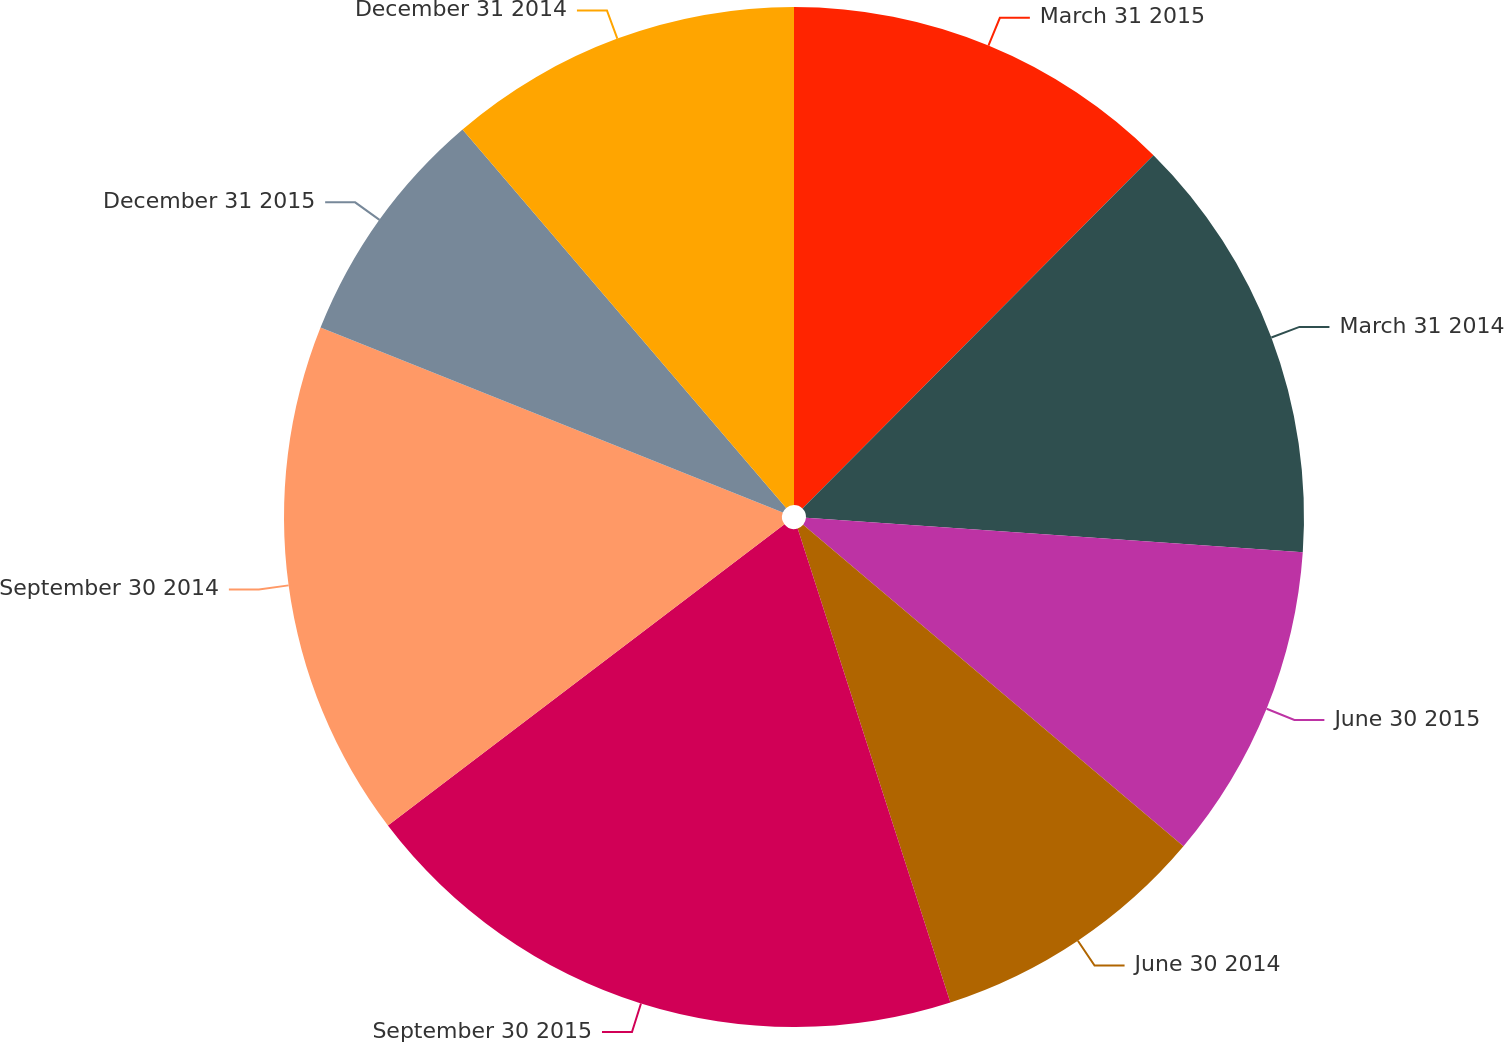Convert chart to OTSL. <chart><loc_0><loc_0><loc_500><loc_500><pie_chart><fcel>March 31 2015<fcel>March 31 2014<fcel>June 30 2015<fcel>June 30 2014<fcel>September 30 2015<fcel>September 30 2014<fcel>December 31 2015<fcel>December 31 2014<nl><fcel>12.45%<fcel>13.65%<fcel>10.07%<fcel>8.87%<fcel>19.62%<fcel>16.4%<fcel>7.68%<fcel>11.26%<nl></chart> 